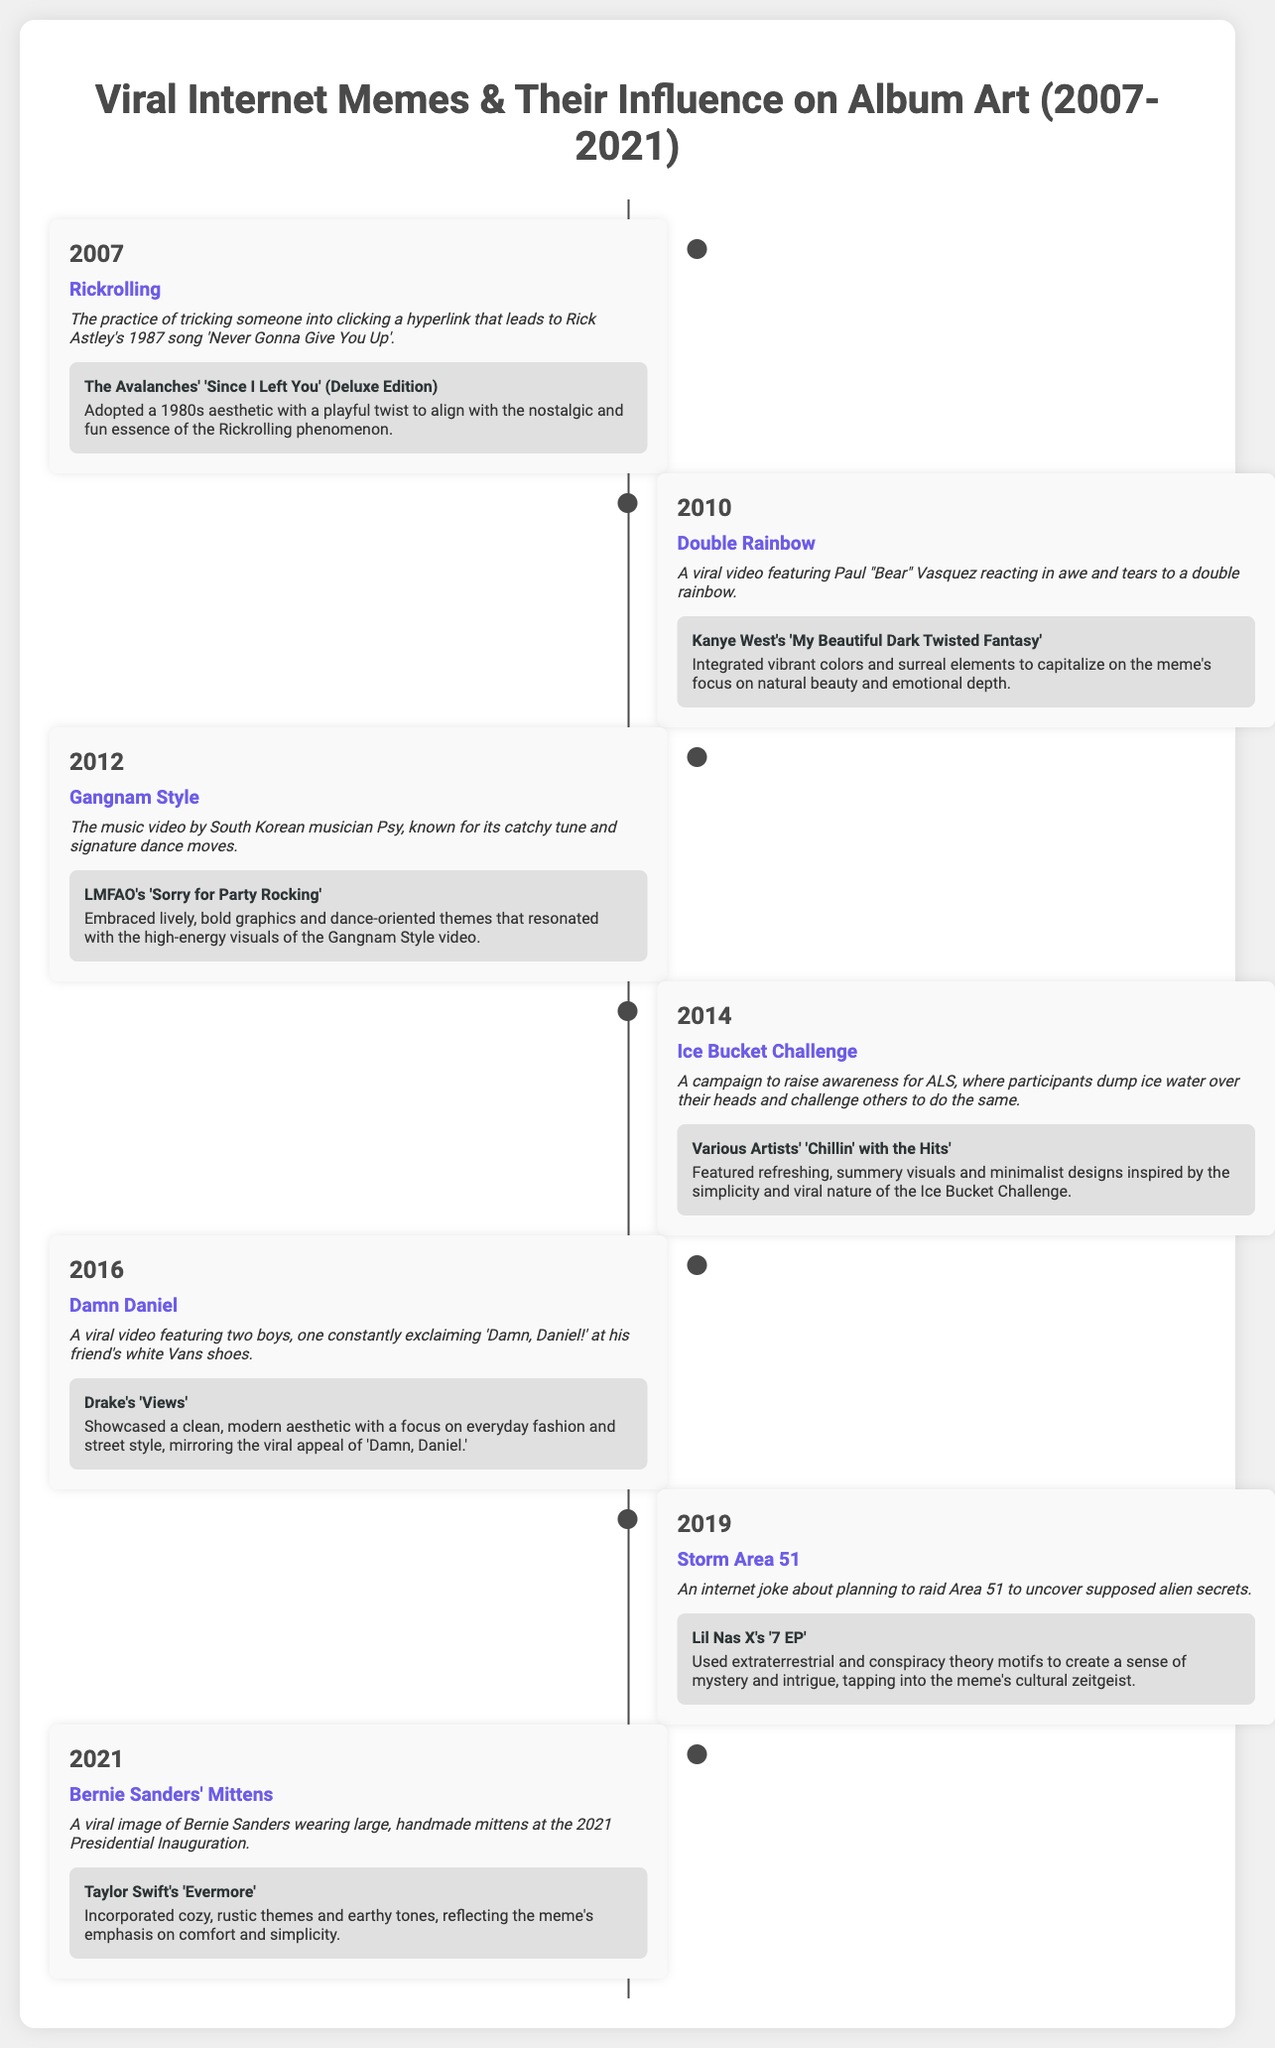What year did Rickrolling become popular? Rickrolling is listed under the year 2007 in the timeline.
Answer: 2007 Which meme was associated with Kanye West's album 'My Beautiful Dark Twisted Fantasy'? The meme 'Double Rainbow' relates to Kanye West's album in 2010.
Answer: Double Rainbow What album features visuals inspired by the Ice Bucket Challenge? The album 'Chillin' with the Hits' is connected to the Ice Bucket Challenge meme in 2014.
Answer: Chillin' with the Hits How many years are represented in the timeline? The timeline covers from 2007 to 2021, which is a span of 15 years.
Answer: 15 Which album incorporated cozy, rustic themes reflecting the Bernie Sanders' mittens meme? The album 'Evermore' by Taylor Swift is associated with the Bernie Sanders' mittens meme in 2021.
Answer: Evermore What visual elements were adopted by LMFAO for their album due to the Gangnam Style meme? LMFAO's album used lively, bold graphics inspired by Gangnam Style.
Answer: Lively, bold graphics What meme featured Paul "Bear" Vasquez? The 'Double Rainbow' meme features Paul "Bear" Vasquez reacting to a natural phenomenon.
Answer: Double Rainbow In what year was the 'Damn Daniel' meme popular? The timeline shows the 'Damn Daniel' meme was notable in 2016.
Answer: 2016 Which artist's album used extraterrestrial motifs linked to the Storm Area 51 meme? The album '7 EP' by Lil Nas X is connected to Storm Area 51 in 2019.
Answer: 7 EP 